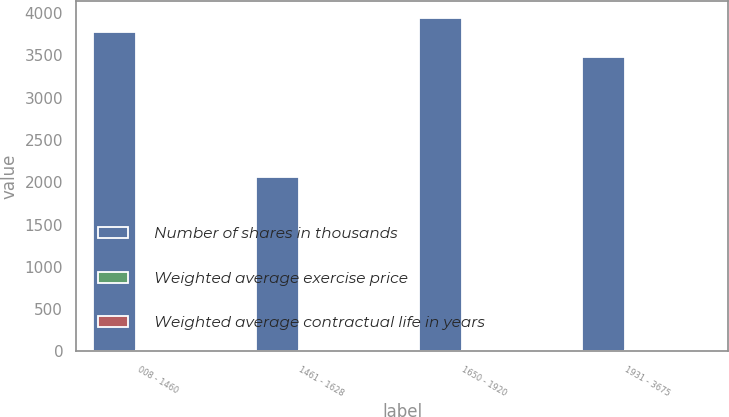Convert chart. <chart><loc_0><loc_0><loc_500><loc_500><stacked_bar_chart><ecel><fcel>008 - 1460<fcel>1461 - 1628<fcel>1650 - 1920<fcel>1931 - 3675<nl><fcel>Number of shares in thousands<fcel>3770<fcel>2065<fcel>3939<fcel>3479<nl><fcel>Weighted average exercise price<fcel>11.89<fcel>15.49<fcel>17.73<fcel>22.61<nl><fcel>Weighted average contractual life in years<fcel>6.7<fcel>8<fcel>6.8<fcel>6.3<nl></chart> 